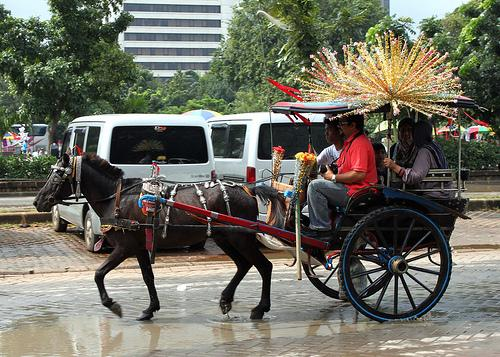Determine how many legs of the horse are visible and their positions. All four legs of the horse are visible - two front legs and two back legs. Describe the appearance and color of the wheel on the carriage. The wheel is big, round, and has black and blue colors. Analyze the interaction between the horse and the carriage. The horse is pulling the carriage with people riding in it, and they are all moving together through water. What is the purpose of the multicolored umbrella in the scene? The multicolored umbrella is used for providing shade. Give a brief description of the background elements in the image. There are green trees in the background and a tall white building with many windows. Identify the type of vehicle being pulled by the horse and the condition of the environment it is in. The horse is pulling a small carriage with people sitting in it and it is walking through a puddle of water. What is the color of the horse and what kind of headdress is it wearing? The horse is brown and it is wearing a decorative headdress. Identify the parts and colors of the horse's body that are visible in the image. The horse's legs, mane, and headdress can be seen. The horse is brown, and the mane is a slightly lighter color. Count the number of people in the carriage and describe their activities. There are four people in the carriage; one man is wearing a red shirt, another man is holding a camera, and the other two are just sitting. Describe the man wearing the red shirt. The man is sitting in the carriage, wearing a red shirt and gray pants. He is holding a camera and has a watch on his forearm and hand. Is the horse wearing a green headdress? The instruction is misleading because the horse is not wearing a green headdress, but a different color headdress is mentioned (X:23 Y:112 Width:75 Height:75). Can you see a woman wearing a blue dress in the carriage? The instruction is misleading because there is no information about anyone in the carriage wearing a blue dress (X:287 Y:104 Width:181 Height:181). Is there a yellow umbrella providing shade for the people in the carriage? The instruction is misleading because the umbrella mentioned is multicolored, not yellow (X:463 Y:121 Width:30 Height:30). Is the man in the red shirt wearing a hat? The instruction is misleading because there is no information about the man in the red shirt wearing a hat (X:331 Y:105 Width:51 Height:51). Are the wheels on the carriage yellow and green? The instruction is misleading because the wheels are described as being black and blue, not yellow and green (X:328 Y:197 Width:131 Height:131). Do the trees in the background have red leaves? The instruction is misleading because there is no information about the color of the leaves on the trees in the background (X:1 Y:2 Width:498 Height:498). 